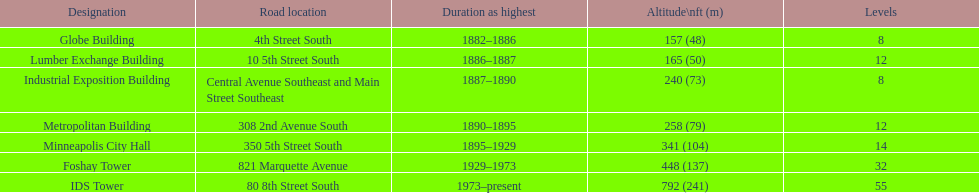Which building has the same number of floors as the lumber exchange building? Metropolitan Building. Would you mind parsing the complete table? {'header': ['Designation', 'Road location', 'Duration as highest', 'Altitude\\nft (m)', 'Levels'], 'rows': [['Globe Building', '4th Street South', '1882–1886', '157 (48)', '8'], ['Lumber Exchange Building', '10 5th Street South', '1886–1887', '165 (50)', '12'], ['Industrial Exposition Building', 'Central Avenue Southeast and Main Street Southeast', '1887–1890', '240 (73)', '8'], ['Metropolitan Building', '308 2nd Avenue South', '1890–1895', '258 (79)', '12'], ['Minneapolis City Hall', '350 5th Street South', '1895–1929', '341 (104)', '14'], ['Foshay Tower', '821 Marquette Avenue', '1929–1973', '448 (137)', '32'], ['IDS Tower', '80 8th Street South', '1973–present', '792 (241)', '55']]} 